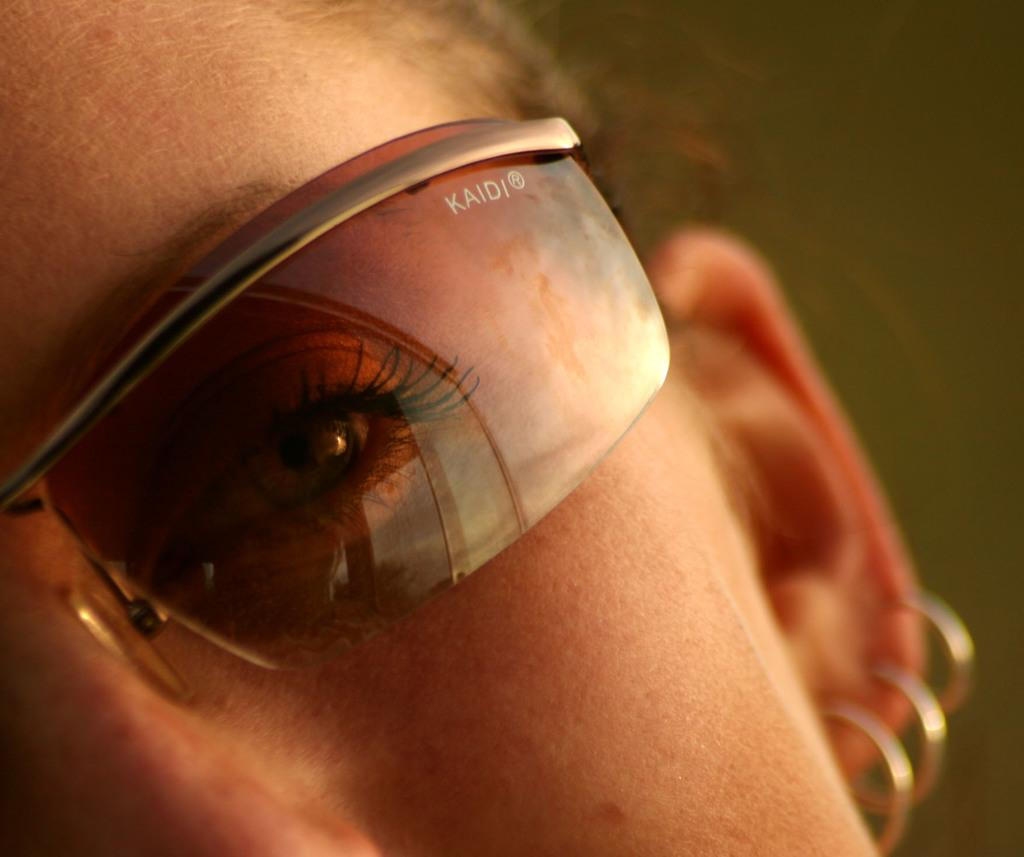What is the main subject of the image? There is a person's face in the image. What accessories is the person wearing in the image? The person is wearing spectacles and earrings in the image. How would you describe the background of the image? The background of the image is blurry. Can you tell me how many donkeys are visible in the image? There are no donkeys present in the image. What color is the hydrant next to the person's face in the image? There is no hydrant present in the image. 